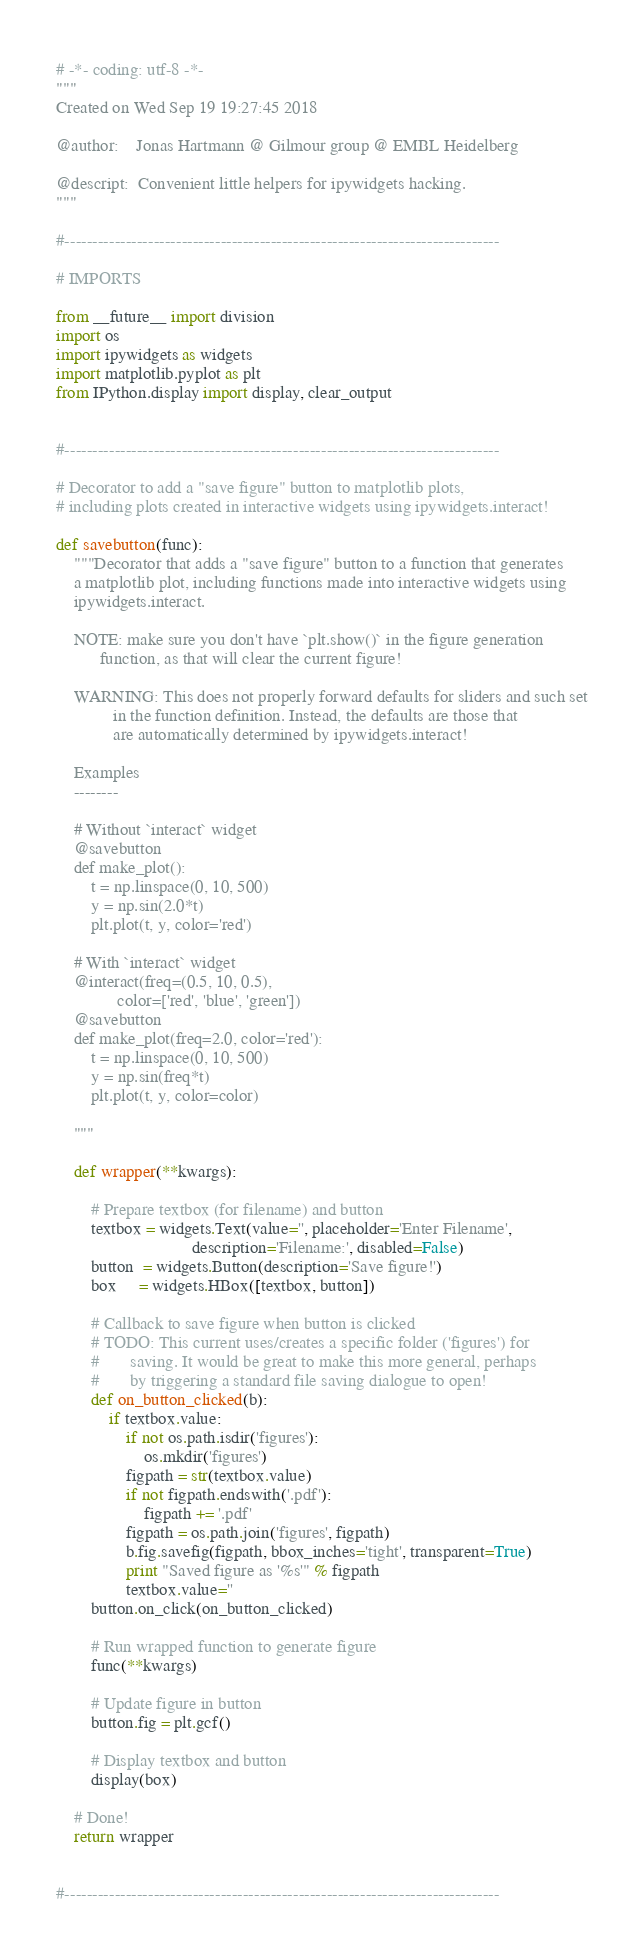Convert code to text. <code><loc_0><loc_0><loc_500><loc_500><_Python_># -*- coding: utf-8 -*-
"""
Created on Wed Sep 19 19:27:45 2018

@author:    Jonas Hartmann @ Gilmour group @ EMBL Heidelberg

@descript:  Convenient little helpers for ipywidgets hacking.
"""

#------------------------------------------------------------------------------

# IMPORTS

from __future__ import division
import os
import ipywidgets as widgets
import matplotlib.pyplot as plt
from IPython.display import display, clear_output


#------------------------------------------------------------------------------

# Decorator to add a "save figure" button to matplotlib plots,
# including plots created in interactive widgets using ipywidgets.interact!

def savebutton(func):
    """Decorator that adds a "save figure" button to a function that generates
    a matplotlib plot, including functions made into interactive widgets using
    ipywidgets.interact.
    
    NOTE: make sure you don't have `plt.show()` in the figure generation
          function, as that will clear the current figure!
          
    WARNING: This does not properly forward defaults for sliders and such set
             in the function definition. Instead, the defaults are those that
             are automatically determined by ipywidgets.interact!
          
    Examples
    --------
    
    # Without `interact` widget
    @savebutton
    def make_plot():
        t = np.linspace(0, 10, 500)
        y = np.sin(2.0*t)
        plt.plot(t, y, color='red')

    # With `interact` widget
    @interact(freq=(0.5, 10, 0.5),
              color=['red', 'blue', 'green'])
    @savebutton
    def make_plot(freq=2.0, color='red'):
        t = np.linspace(0, 10, 500)
        y = np.sin(freq*t)
        plt.plot(t, y, color=color)
    
    """
        
    def wrapper(**kwargs):
        
        # Prepare textbox (for filename) and button
        textbox = widgets.Text(value='', placeholder='Enter Filename',
                               description='Filename:', disabled=False)
        button  = widgets.Button(description='Save figure!')
        box     = widgets.HBox([textbox, button])
        
        # Callback to save figure when button is clicked
        # TODO: This current uses/creates a specific folder ('figures') for
        #       saving. It would be great to make this more general, perhaps 
        #       by triggering a standard file saving dialogue to open!
        def on_button_clicked(b):
            if textbox.value:
                if not os.path.isdir('figures'):
                    os.mkdir('figures')
                figpath = str(textbox.value)
                if not figpath.endswith('.pdf'):
                    figpath += '.pdf'
                figpath = os.path.join('figures', figpath)
                b.fig.savefig(figpath, bbox_inches='tight', transparent=True)
                print "Saved figure as '%s'" % figpath
                textbox.value=''
        button.on_click(on_button_clicked)
        
        # Run wrapped function to generate figure
        func(**kwargs)
        
        # Update figure in button
        button.fig = plt.gcf()
        
        # Display textbox and button
        display(box)
        
    # Done!
    return wrapper  


#------------------------------------------------------------------------------



</code> 